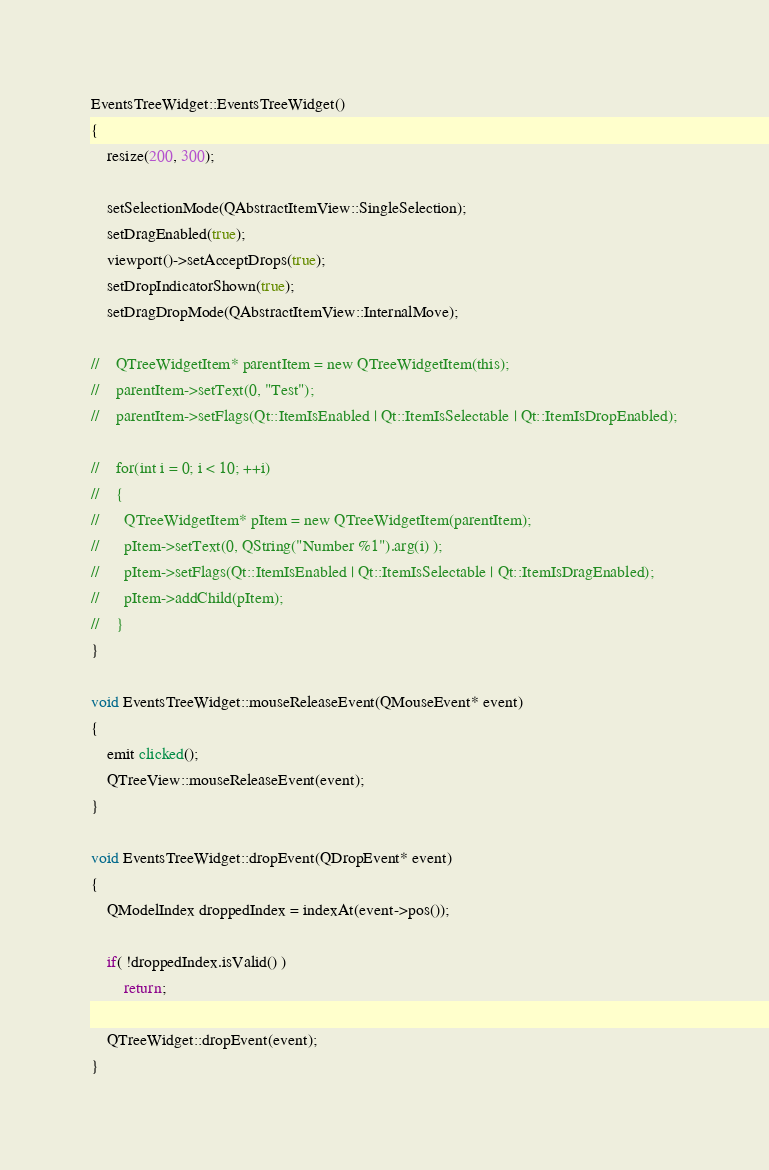Convert code to text. <code><loc_0><loc_0><loc_500><loc_500><_C++_>
EventsTreeWidget::EventsTreeWidget()
{
    resize(200, 300);

    setSelectionMode(QAbstractItemView::SingleSelection);
    setDragEnabled(true);
    viewport()->setAcceptDrops(true);
    setDropIndicatorShown(true);
    setDragDropMode(QAbstractItemView::InternalMove);

//    QTreeWidgetItem* parentItem = new QTreeWidgetItem(this);
//    parentItem->setText(0, "Test");
//    parentItem->setFlags(Qt::ItemIsEnabled | Qt::ItemIsSelectable | Qt::ItemIsDropEnabled);

//    for(int i = 0; i < 10; ++i)
//    {
//      QTreeWidgetItem* pItem = new QTreeWidgetItem(parentItem);
//      pItem->setText(0, QString("Number %1").arg(i) );
//      pItem->setFlags(Qt::ItemIsEnabled | Qt::ItemIsSelectable | Qt::ItemIsDragEnabled);
//      pItem->addChild(pItem);
//    }
}

void EventsTreeWidget::mouseReleaseEvent(QMouseEvent* event)
{
    emit clicked();
    QTreeView::mouseReleaseEvent(event);
}

void EventsTreeWidget::dropEvent(QDropEvent* event)
{
    QModelIndex droppedIndex = indexAt(event->pos());

    if( !droppedIndex.isValid() )
        return;

    QTreeWidget::dropEvent(event);
}
</code> 